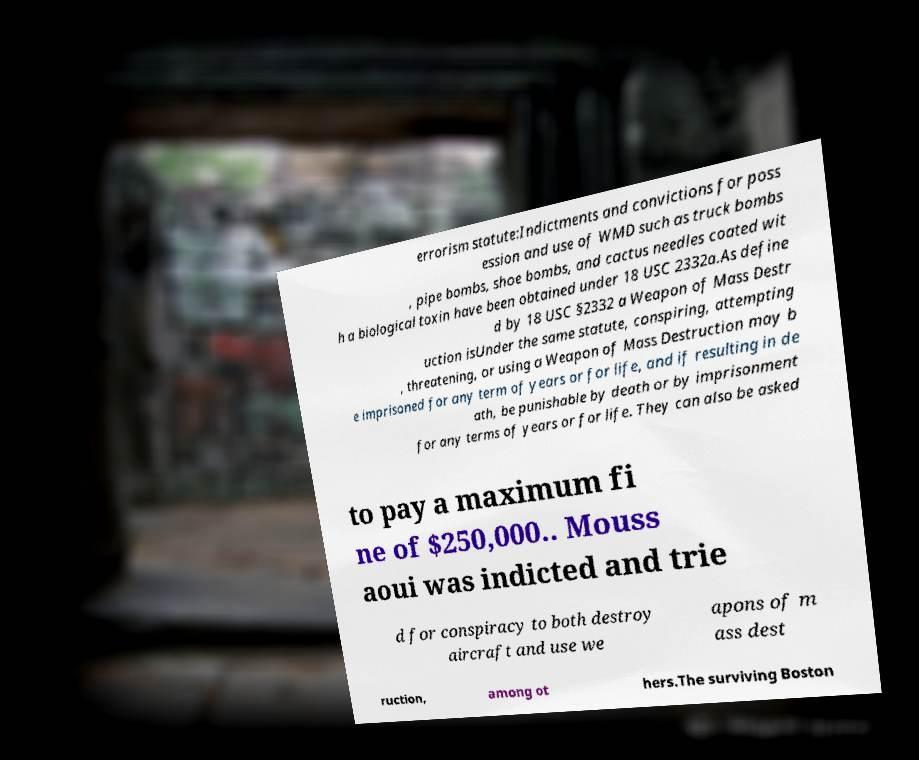I need the written content from this picture converted into text. Can you do that? errorism statute:Indictments and convictions for poss ession and use of WMD such as truck bombs , pipe bombs, shoe bombs, and cactus needles coated wit h a biological toxin have been obtained under 18 USC 2332a.As define d by 18 USC §2332 a Weapon of Mass Destr uction isUnder the same statute, conspiring, attempting , threatening, or using a Weapon of Mass Destruction may b e imprisoned for any term of years or for life, and if resulting in de ath, be punishable by death or by imprisonment for any terms of years or for life. They can also be asked to pay a maximum fi ne of $250,000.. Mouss aoui was indicted and trie d for conspiracy to both destroy aircraft and use we apons of m ass dest ruction, among ot hers.The surviving Boston 